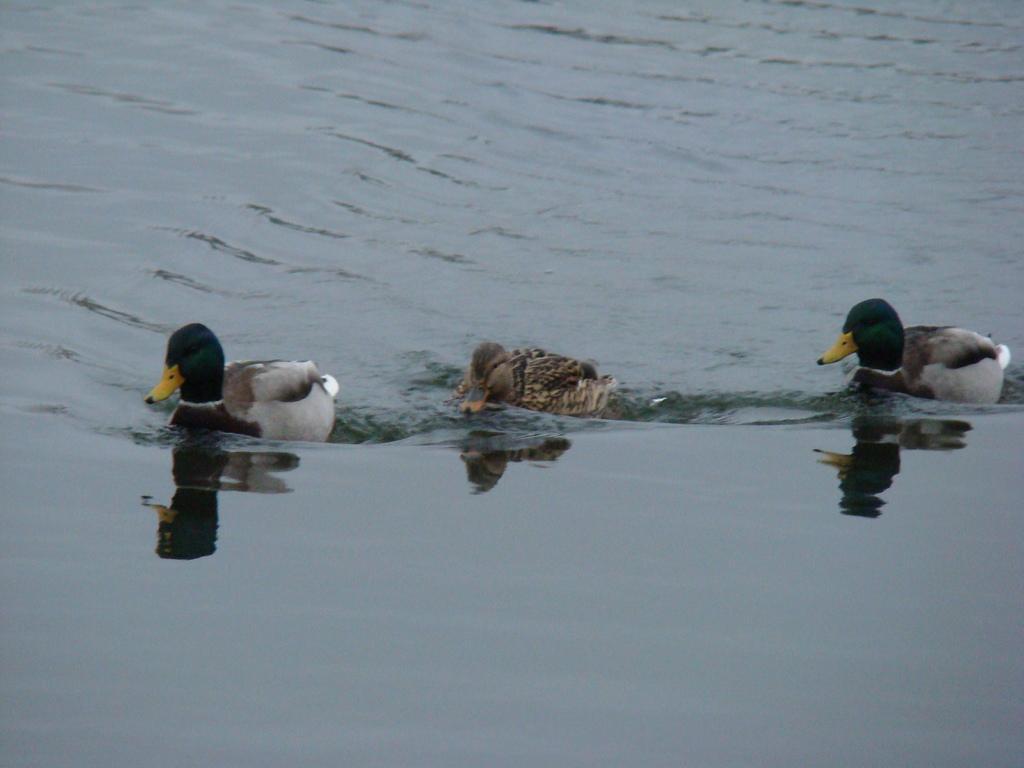Please provide a concise description of this image. In this image, I can see three ducks moving in the water. 